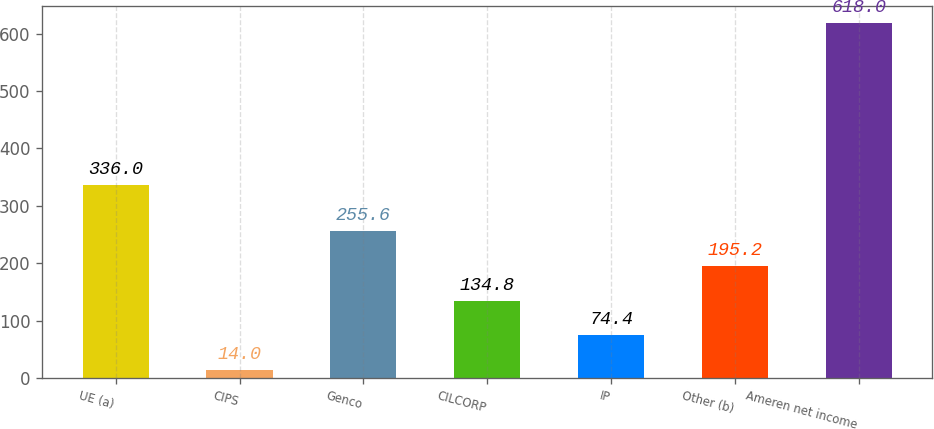Convert chart. <chart><loc_0><loc_0><loc_500><loc_500><bar_chart><fcel>UE (a)<fcel>CIPS<fcel>Genco<fcel>CILCORP<fcel>IP<fcel>Other (b)<fcel>Ameren net income<nl><fcel>336<fcel>14<fcel>255.6<fcel>134.8<fcel>74.4<fcel>195.2<fcel>618<nl></chart> 